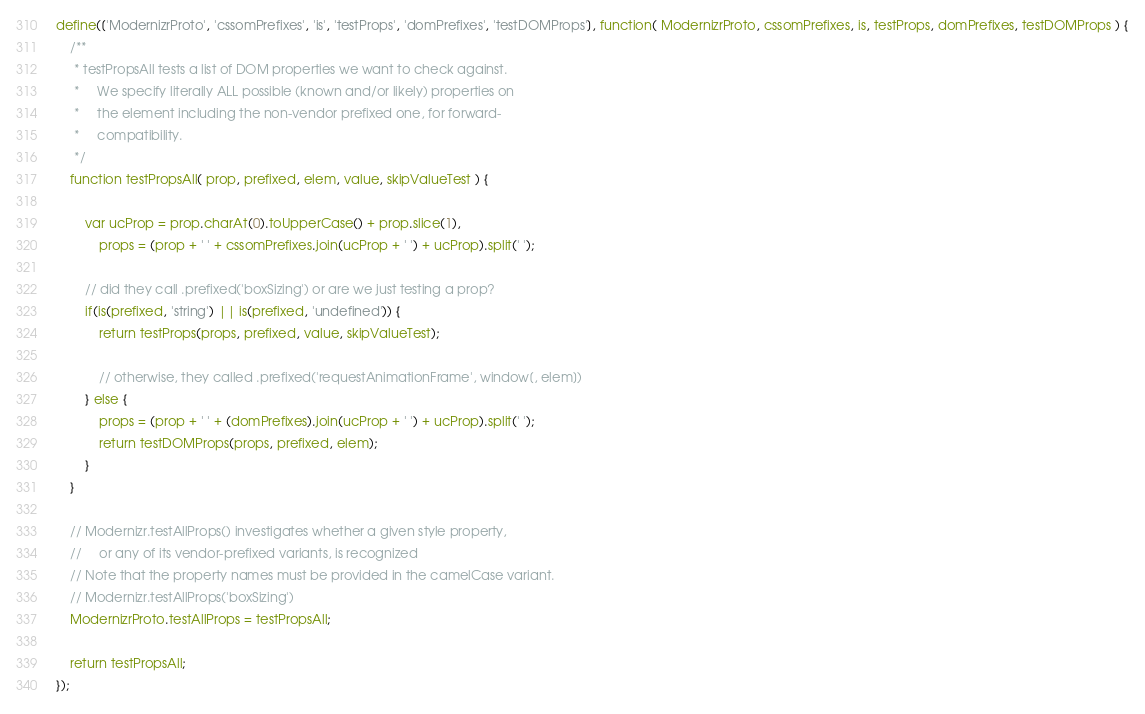<code> <loc_0><loc_0><loc_500><loc_500><_JavaScript_>define(['ModernizrProto', 'cssomPrefixes', 'is', 'testProps', 'domPrefixes', 'testDOMProps'], function( ModernizrProto, cssomPrefixes, is, testProps, domPrefixes, testDOMProps ) {
    /**
     * testPropsAll tests a list of DOM properties we want to check against.
     *     We specify literally ALL possible (known and/or likely) properties on
     *     the element including the non-vendor prefixed one, for forward-
     *     compatibility.
     */
    function testPropsAll( prop, prefixed, elem, value, skipValueTest ) {

        var ucProp = prop.charAt(0).toUpperCase() + prop.slice(1),
            props = (prop + ' ' + cssomPrefixes.join(ucProp + ' ') + ucProp).split(' ');

        // did they call .prefixed('boxSizing') or are we just testing a prop?
        if(is(prefixed, 'string') || is(prefixed, 'undefined')) {
            return testProps(props, prefixed, value, skipValueTest);

            // otherwise, they called .prefixed('requestAnimationFrame', window[, elem])
        } else {
            props = (prop + ' ' + (domPrefixes).join(ucProp + ' ') + ucProp).split(' ');
            return testDOMProps(props, prefixed, elem);
        }
    }

    // Modernizr.testAllProps() investigates whether a given style property,
    //     or any of its vendor-prefixed variants, is recognized
    // Note that the property names must be provided in the camelCase variant.
    // Modernizr.testAllProps('boxSizing')
    ModernizrProto.testAllProps = testPropsAll;

    return testPropsAll;
});
</code> 